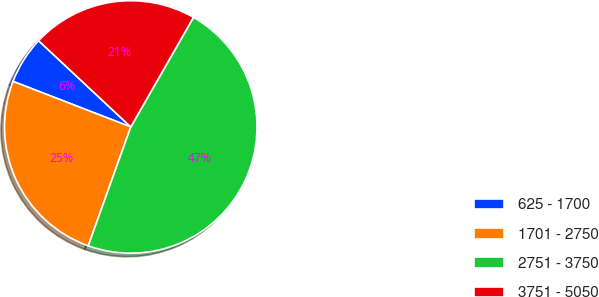Convert chart to OTSL. <chart><loc_0><loc_0><loc_500><loc_500><pie_chart><fcel>625 - 1700<fcel>1701 - 2750<fcel>2751 - 3750<fcel>3751 - 5050<nl><fcel>6.1%<fcel>25.41%<fcel>47.2%<fcel>21.3%<nl></chart> 